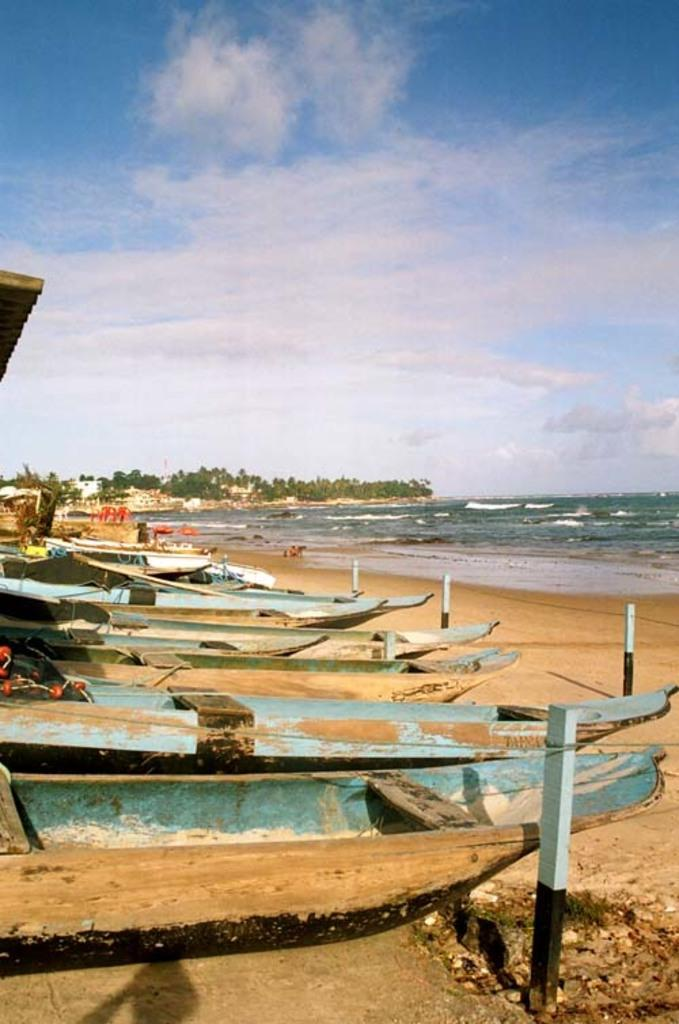What type of vehicles can be seen on the seashore in the image? There are boats on the seashore in the image. What is visible on the right side of the image? There is water on the right side of the image. What color is the sky in the image? The sky is blue in color. Where is the hen located in the image? There is no hen present in the image. What type of brake system is used by the boats in the image? The image does not provide information about the boats' brake systems. 